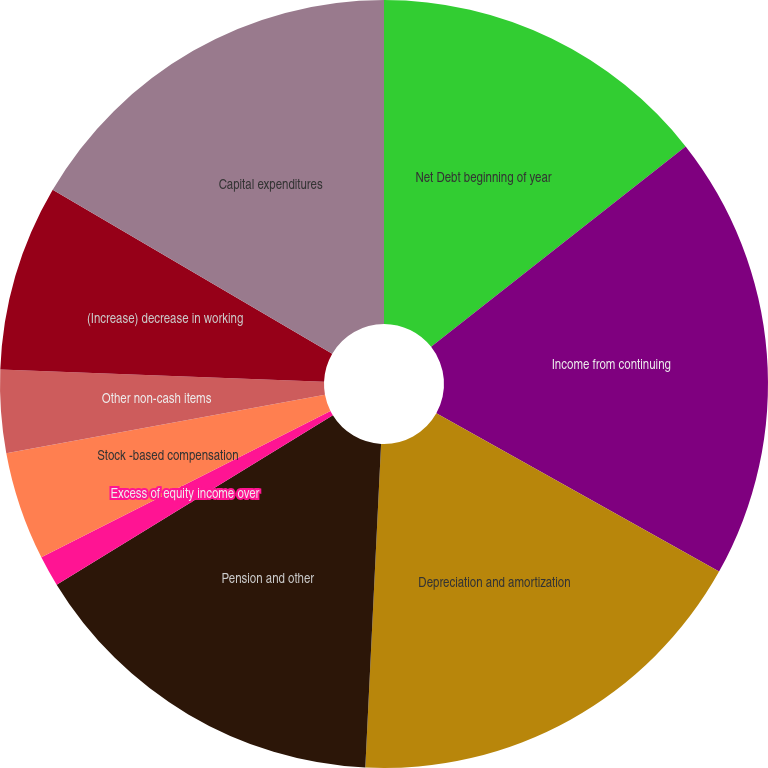Convert chart. <chart><loc_0><loc_0><loc_500><loc_500><pie_chart><fcel>Net Debt beginning of year<fcel>Income from continuing<fcel>Depreciation and amortization<fcel>Pension and other<fcel>Excess of equity income over<fcel>Stock -based compensation<fcel>Other non-cash items<fcel>(Increase) decrease in working<fcel>Capital expenditures<nl><fcel>14.38%<fcel>18.74%<fcel>17.65%<fcel>15.47%<fcel>1.3%<fcel>4.57%<fcel>3.48%<fcel>7.84%<fcel>16.56%<nl></chart> 